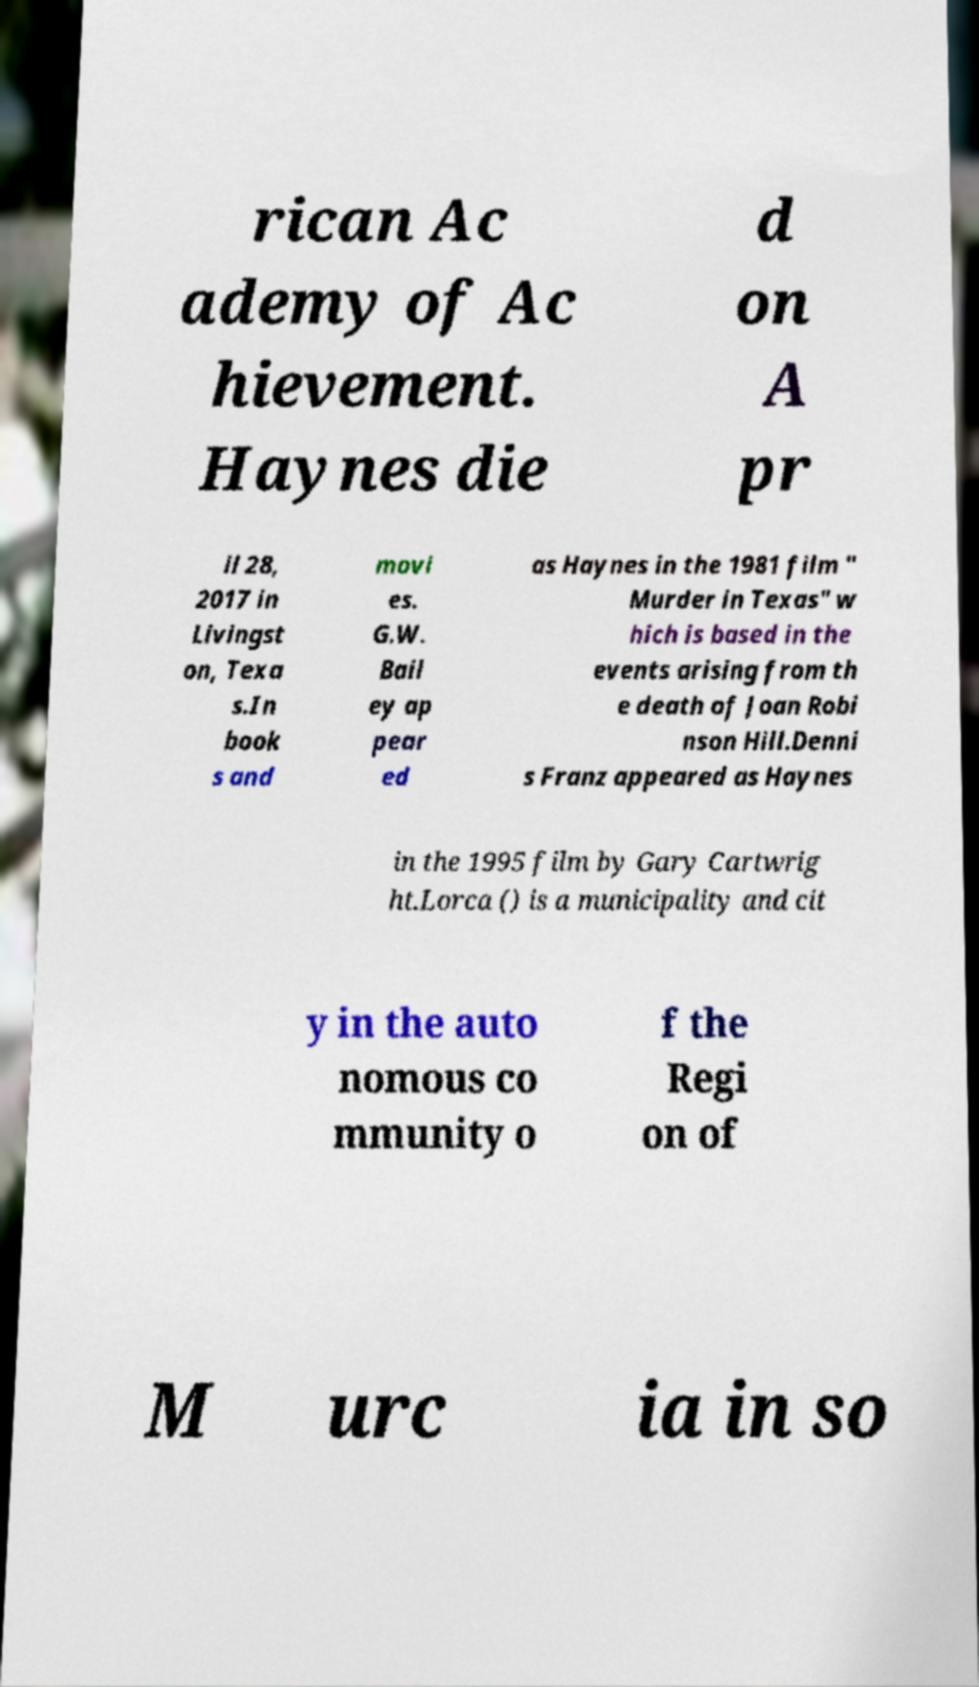Could you assist in decoding the text presented in this image and type it out clearly? rican Ac ademy of Ac hievement. Haynes die d on A pr il 28, 2017 in Livingst on, Texa s.In book s and movi es. G.W. Bail ey ap pear ed as Haynes in the 1981 film " Murder in Texas" w hich is based in the events arising from th e death of Joan Robi nson Hill.Denni s Franz appeared as Haynes in the 1995 film by Gary Cartwrig ht.Lorca () is a municipality and cit y in the auto nomous co mmunity o f the Regi on of M urc ia in so 